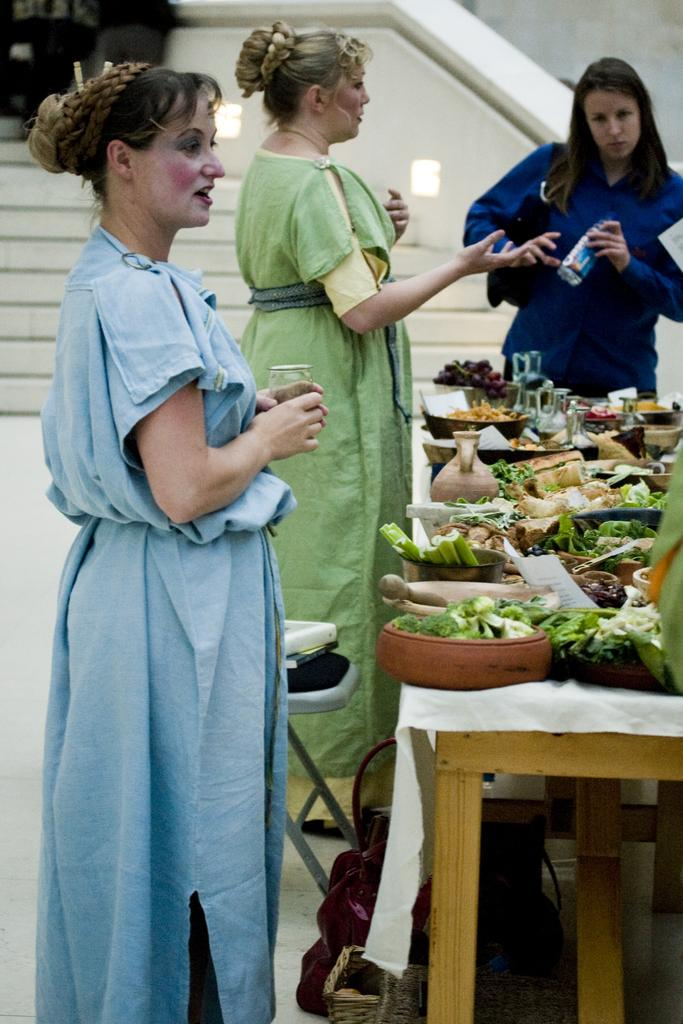How many people are in the image? There are three people standing in the image. What is the purpose of the table in the image? The table is present in the image, and food items are placed on it. Can you describe the location of the stairs in the image? There are stairs visible in the image. What type of plantation can be seen in the image? There is no plantation present in the image. Is there any shade provided by trees or structures in the image? The image does not show any trees or structures that could provide shade. 